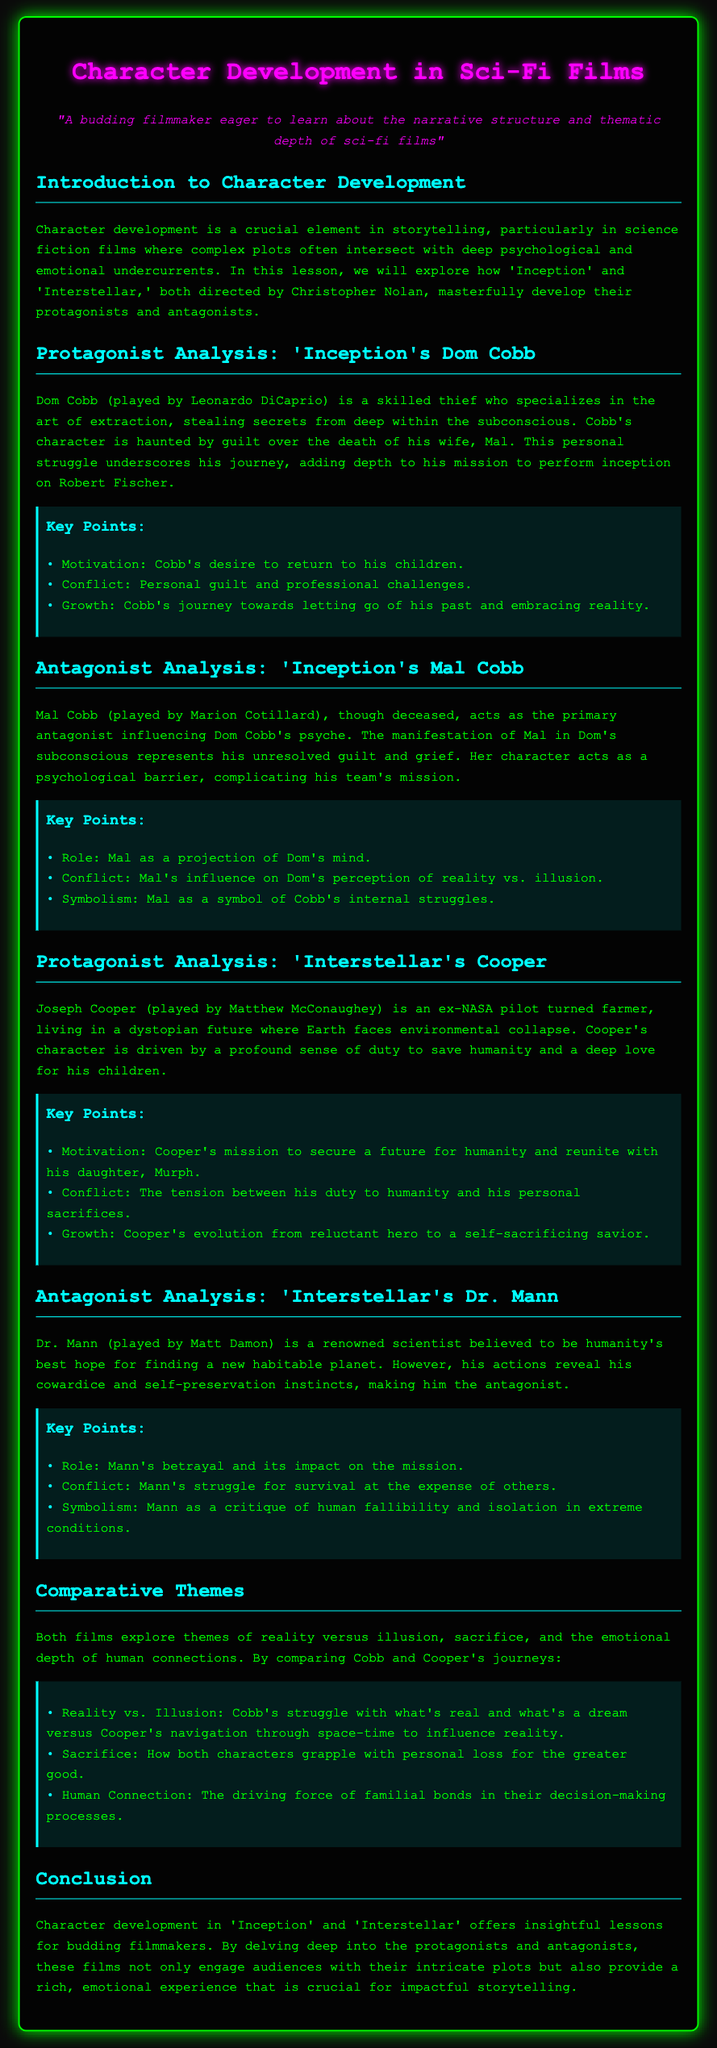what is the title of the lesson plan? The title of the lesson plan is explicitly stated at the beginning of the document.
Answer: Character Development in Sci-Fi Films who plays the character Dom Cobb in 'Inception'? The document provides the name of the actor who portrays Dom Cobb in the film.
Answer: Leonardo DiCaprio what psychological barrier does Mal Cobb represent in 'Inception'? The lesson plan describes Mal as a manifestation influencing Dom Cobb's psyche, thus representing a specific emotional struggle.
Answer: Unresolved guilt and grief what is Joseph Cooper's primary motivation in 'Interstellar'? The document outlines Cooper's motivations, focusing on his sense of duty and personal connections.
Answer: To secure a future for humanity and reunite with his daughter who is identified as the antagonist in 'Interstellar'? The lesson plan specifies the character acting as the antagonist in 'Interstellar'.
Answer: Dr. Mann how do both protagonists (Cobb and Cooper) grapple with personal loss? The document discusses the theme of sacrifice as a shared experience for both characters, indicating their challenges.
Answer: By personal loss for the greater good what theme is explored in both films related to reality? The lesson plan highlights a contrasting theme within the characters' experiences, particularly regarding perception.
Answer: Reality vs. Illusion what key point is associated with Cobb's character growth? The document lists distinct elements of growth for Cobb within his character analysis.
Answer: Letting go of his past and embracing reality 